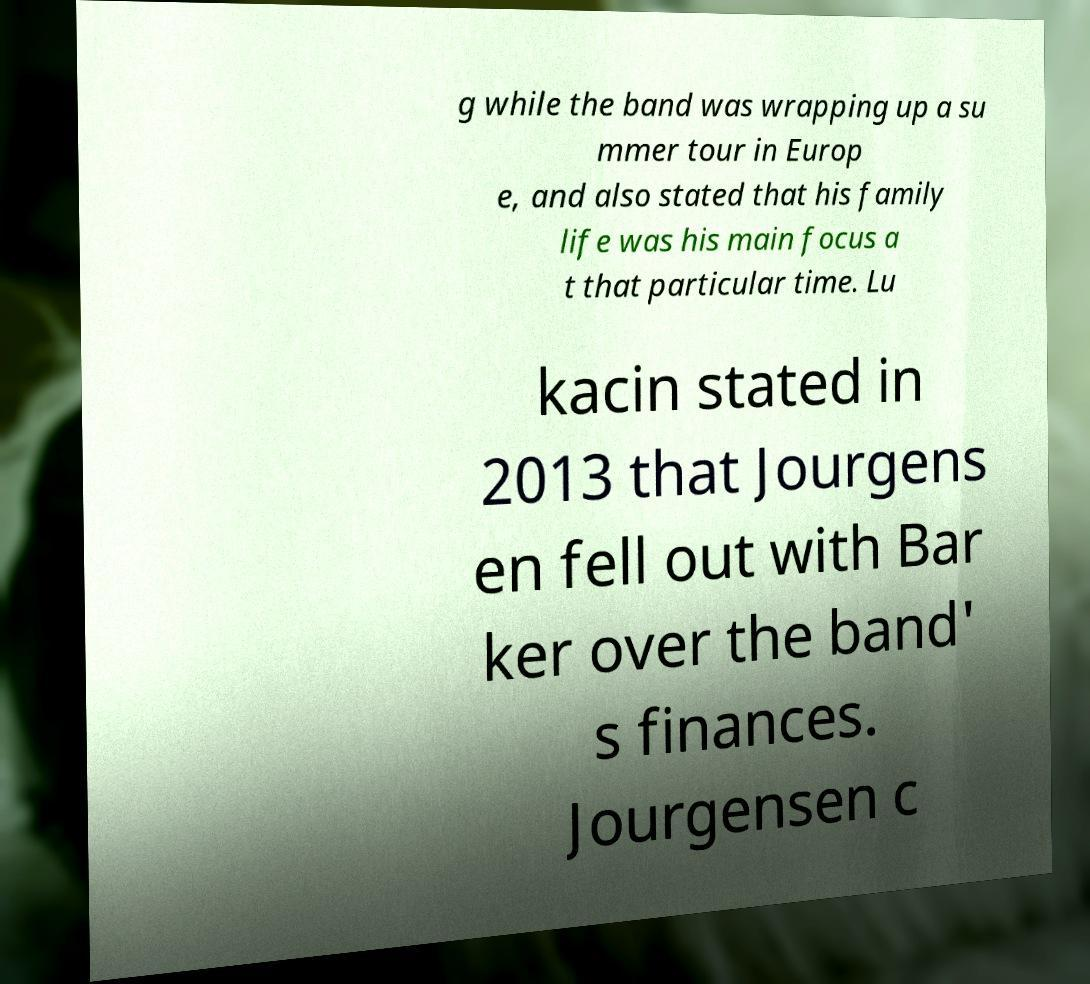What messages or text are displayed in this image? I need them in a readable, typed format. g while the band was wrapping up a su mmer tour in Europ e, and also stated that his family life was his main focus a t that particular time. Lu kacin stated in 2013 that Jourgens en fell out with Bar ker over the band' s finances. Jourgensen c 